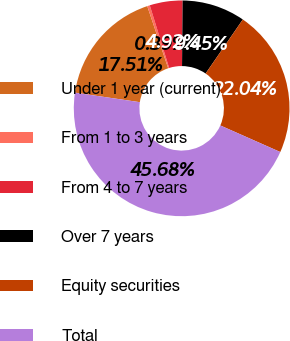Convert chart to OTSL. <chart><loc_0><loc_0><loc_500><loc_500><pie_chart><fcel>Under 1 year (current)<fcel>From 1 to 3 years<fcel>From 4 to 7 years<fcel>Over 7 years<fcel>Equity securities<fcel>Total<nl><fcel>17.51%<fcel>0.39%<fcel>4.92%<fcel>9.45%<fcel>22.04%<fcel>45.68%<nl></chart> 